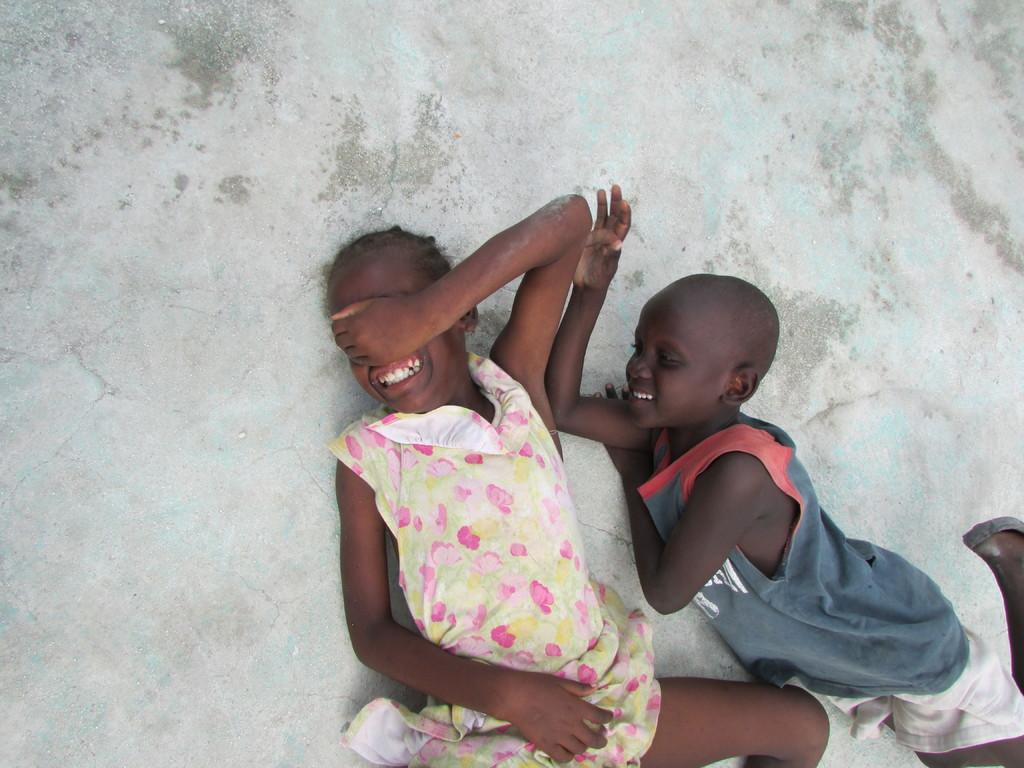How would you summarize this image in a sentence or two? At the bottom of this image, there is a girl lying on the floor. Beside this girl, there is a boy, smiling and lying on the floor. And the background is gray in color. 